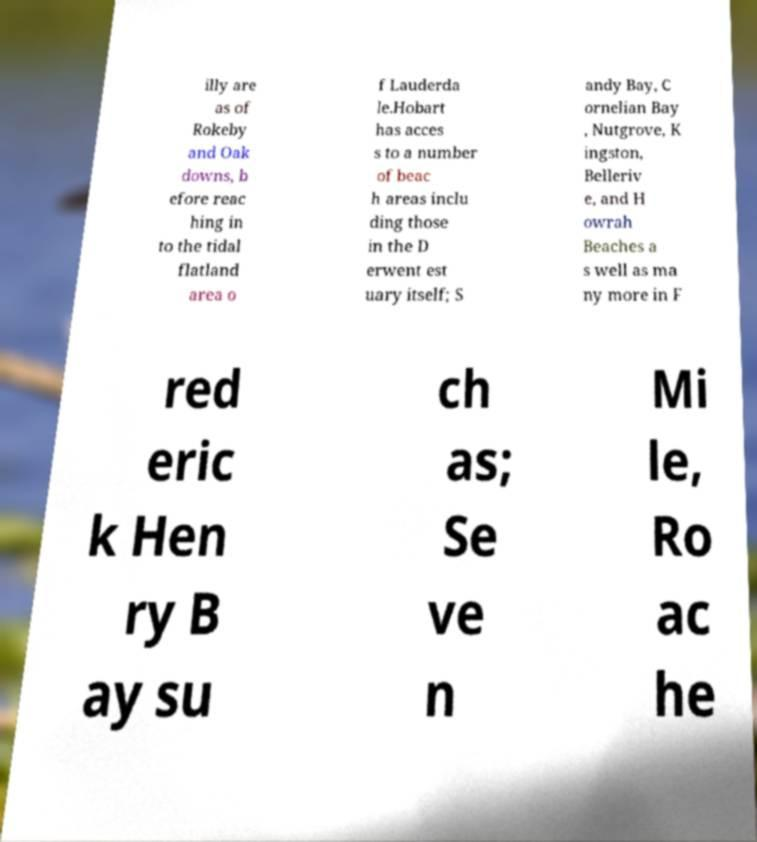Please identify and transcribe the text found in this image. illy are as of Rokeby and Oak downs, b efore reac hing in to the tidal flatland area o f Lauderda le.Hobart has acces s to a number of beac h areas inclu ding those in the D erwent est uary itself; S andy Bay, C ornelian Bay , Nutgrove, K ingston, Belleriv e, and H owrah Beaches a s well as ma ny more in F red eric k Hen ry B ay su ch as; Se ve n Mi le, Ro ac he 